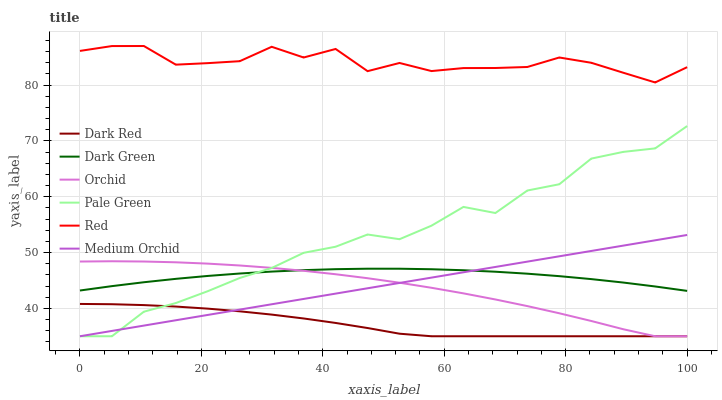Does Medium Orchid have the minimum area under the curve?
Answer yes or no. No. Does Medium Orchid have the maximum area under the curve?
Answer yes or no. No. Is Pale Green the smoothest?
Answer yes or no. No. Is Pale Green the roughest?
Answer yes or no. No. Does Dark Green have the lowest value?
Answer yes or no. No. Does Medium Orchid have the highest value?
Answer yes or no. No. Is Dark Red less than Red?
Answer yes or no. Yes. Is Red greater than Dark Red?
Answer yes or no. Yes. Does Dark Red intersect Red?
Answer yes or no. No. 